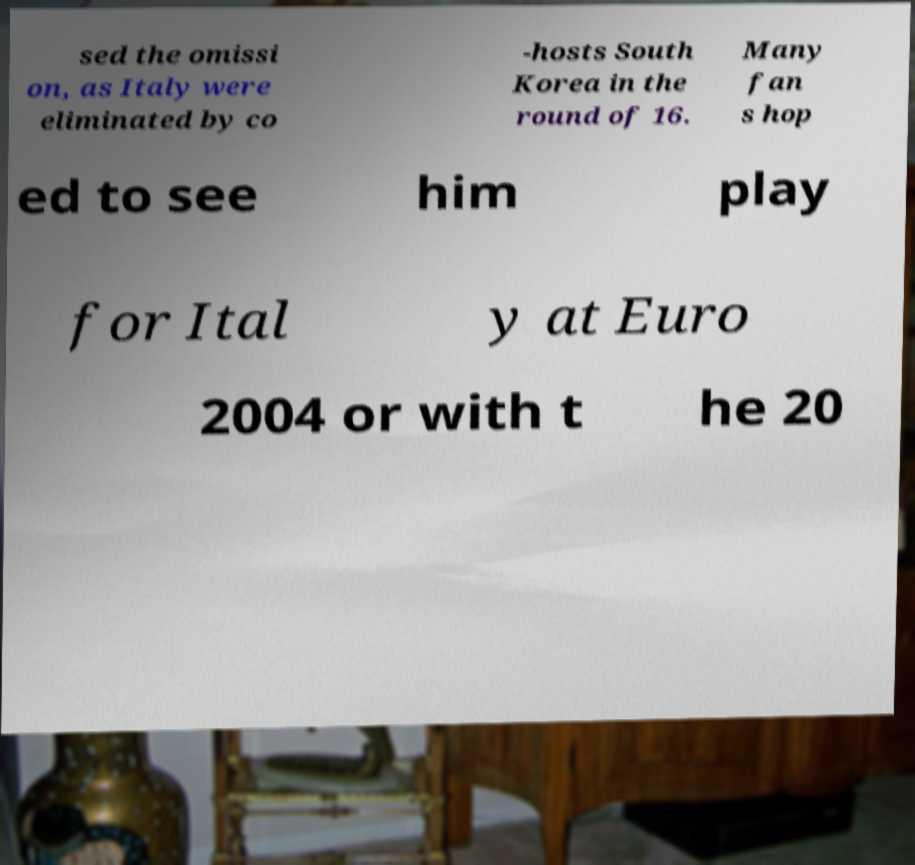What messages or text are displayed in this image? I need them in a readable, typed format. sed the omissi on, as Italy were eliminated by co -hosts South Korea in the round of 16. Many fan s hop ed to see him play for Ital y at Euro 2004 or with t he 20 